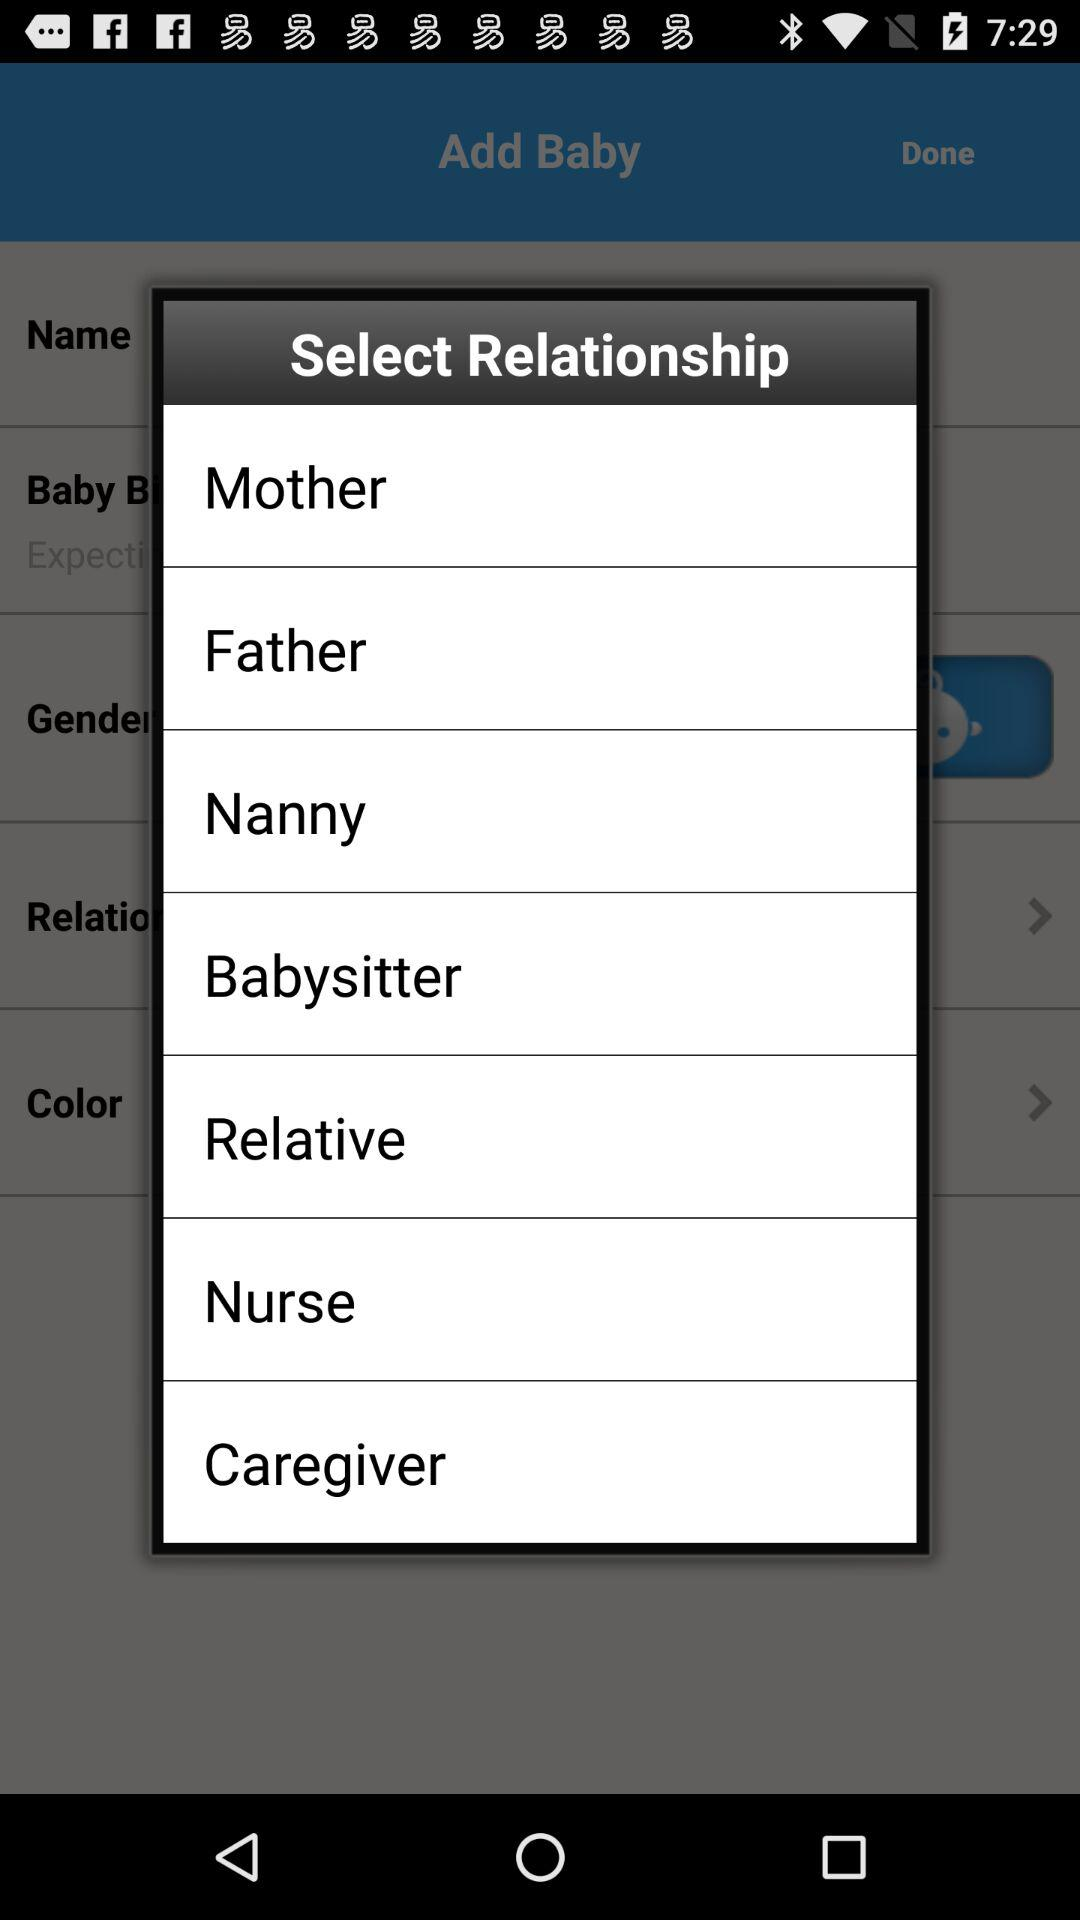What are the options that I can select for my relationship? The options are "Mother", "Father", "Nanny", "Babysitter", "Relative", "Nurse" and "Caregiver". 